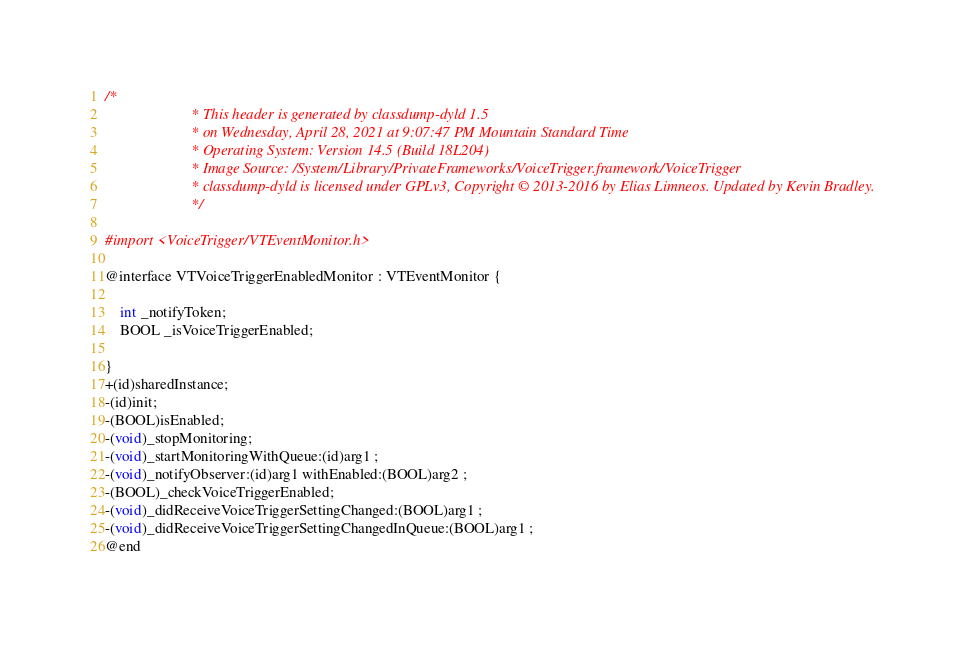Convert code to text. <code><loc_0><loc_0><loc_500><loc_500><_C_>/*
                       * This header is generated by classdump-dyld 1.5
                       * on Wednesday, April 28, 2021 at 9:07:47 PM Mountain Standard Time
                       * Operating System: Version 14.5 (Build 18L204)
                       * Image Source: /System/Library/PrivateFrameworks/VoiceTrigger.framework/VoiceTrigger
                       * classdump-dyld is licensed under GPLv3, Copyright © 2013-2016 by Elias Limneos. Updated by Kevin Bradley.
                       */

#import <VoiceTrigger/VTEventMonitor.h>

@interface VTVoiceTriggerEnabledMonitor : VTEventMonitor {

	int _notifyToken;
	BOOL _isVoiceTriggerEnabled;

}
+(id)sharedInstance;
-(id)init;
-(BOOL)isEnabled;
-(void)_stopMonitoring;
-(void)_startMonitoringWithQueue:(id)arg1 ;
-(void)_notifyObserver:(id)arg1 withEnabled:(BOOL)arg2 ;
-(BOOL)_checkVoiceTriggerEnabled;
-(void)_didReceiveVoiceTriggerSettingChanged:(BOOL)arg1 ;
-(void)_didReceiveVoiceTriggerSettingChangedInQueue:(BOOL)arg1 ;
@end

</code> 